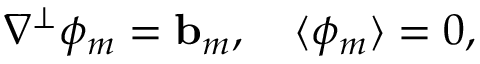Convert formula to latex. <formula><loc_0><loc_0><loc_500><loc_500>\nabla ^ { \perp } \phi _ { m } = { b } _ { m } , \quad \langle \phi _ { m } \rangle = 0 ,</formula> 